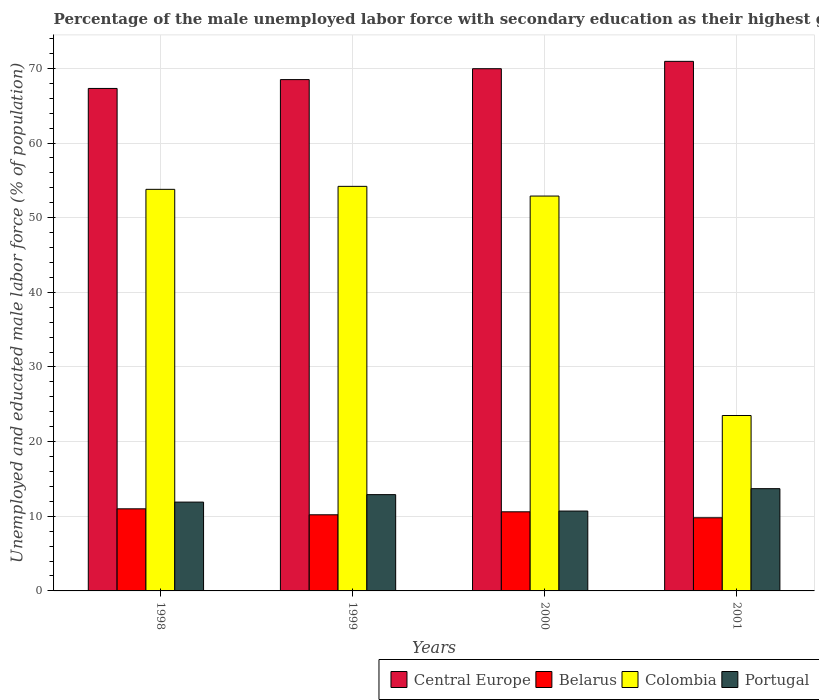How many groups of bars are there?
Offer a very short reply. 4. Are the number of bars on each tick of the X-axis equal?
Give a very brief answer. Yes. How many bars are there on the 1st tick from the right?
Offer a very short reply. 4. What is the label of the 2nd group of bars from the left?
Offer a very short reply. 1999. In how many cases, is the number of bars for a given year not equal to the number of legend labels?
Make the answer very short. 0. What is the percentage of the unemployed male labor force with secondary education in Belarus in 2000?
Make the answer very short. 10.6. Across all years, what is the maximum percentage of the unemployed male labor force with secondary education in Central Europe?
Your answer should be very brief. 70.95. Across all years, what is the minimum percentage of the unemployed male labor force with secondary education in Belarus?
Your answer should be very brief. 9.8. In which year was the percentage of the unemployed male labor force with secondary education in Colombia maximum?
Provide a succinct answer. 1999. In which year was the percentage of the unemployed male labor force with secondary education in Portugal minimum?
Offer a terse response. 2000. What is the total percentage of the unemployed male labor force with secondary education in Colombia in the graph?
Your answer should be compact. 184.4. What is the difference between the percentage of the unemployed male labor force with secondary education in Colombia in 1999 and that in 2000?
Your response must be concise. 1.3. What is the difference between the percentage of the unemployed male labor force with secondary education in Colombia in 2000 and the percentage of the unemployed male labor force with secondary education in Central Europe in 2001?
Your answer should be compact. -18.05. What is the average percentage of the unemployed male labor force with secondary education in Colombia per year?
Give a very brief answer. 46.1. In the year 1999, what is the difference between the percentage of the unemployed male labor force with secondary education in Portugal and percentage of the unemployed male labor force with secondary education in Central Europe?
Ensure brevity in your answer.  -55.6. In how many years, is the percentage of the unemployed male labor force with secondary education in Portugal greater than 56 %?
Keep it short and to the point. 0. What is the ratio of the percentage of the unemployed male labor force with secondary education in Colombia in 1998 to that in 2001?
Make the answer very short. 2.29. Is the percentage of the unemployed male labor force with secondary education in Portugal in 1998 less than that in 1999?
Offer a terse response. Yes. What is the difference between the highest and the second highest percentage of the unemployed male labor force with secondary education in Central Europe?
Your response must be concise. 0.99. What is the difference between the highest and the lowest percentage of the unemployed male labor force with secondary education in Belarus?
Offer a terse response. 1.2. In how many years, is the percentage of the unemployed male labor force with secondary education in Central Europe greater than the average percentage of the unemployed male labor force with secondary education in Central Europe taken over all years?
Your answer should be compact. 2. What does the 1st bar from the left in 1998 represents?
Provide a succinct answer. Central Europe. How many years are there in the graph?
Make the answer very short. 4. Where does the legend appear in the graph?
Your response must be concise. Bottom right. What is the title of the graph?
Provide a short and direct response. Percentage of the male unemployed labor force with secondary education as their highest grade. What is the label or title of the Y-axis?
Offer a terse response. Unemployed and educated male labor force (% of population). What is the Unemployed and educated male labor force (% of population) in Central Europe in 1998?
Provide a succinct answer. 67.32. What is the Unemployed and educated male labor force (% of population) in Belarus in 1998?
Make the answer very short. 11. What is the Unemployed and educated male labor force (% of population) of Colombia in 1998?
Provide a succinct answer. 53.8. What is the Unemployed and educated male labor force (% of population) of Portugal in 1998?
Provide a succinct answer. 11.9. What is the Unemployed and educated male labor force (% of population) in Central Europe in 1999?
Give a very brief answer. 68.5. What is the Unemployed and educated male labor force (% of population) in Belarus in 1999?
Provide a succinct answer. 10.2. What is the Unemployed and educated male labor force (% of population) in Colombia in 1999?
Offer a terse response. 54.2. What is the Unemployed and educated male labor force (% of population) of Portugal in 1999?
Your answer should be compact. 12.9. What is the Unemployed and educated male labor force (% of population) in Central Europe in 2000?
Your response must be concise. 69.96. What is the Unemployed and educated male labor force (% of population) of Belarus in 2000?
Make the answer very short. 10.6. What is the Unemployed and educated male labor force (% of population) in Colombia in 2000?
Offer a very short reply. 52.9. What is the Unemployed and educated male labor force (% of population) in Portugal in 2000?
Make the answer very short. 10.7. What is the Unemployed and educated male labor force (% of population) of Central Europe in 2001?
Your response must be concise. 70.95. What is the Unemployed and educated male labor force (% of population) of Belarus in 2001?
Offer a terse response. 9.8. What is the Unemployed and educated male labor force (% of population) in Portugal in 2001?
Provide a succinct answer. 13.7. Across all years, what is the maximum Unemployed and educated male labor force (% of population) in Central Europe?
Give a very brief answer. 70.95. Across all years, what is the maximum Unemployed and educated male labor force (% of population) of Belarus?
Provide a short and direct response. 11. Across all years, what is the maximum Unemployed and educated male labor force (% of population) in Colombia?
Offer a terse response. 54.2. Across all years, what is the maximum Unemployed and educated male labor force (% of population) of Portugal?
Offer a terse response. 13.7. Across all years, what is the minimum Unemployed and educated male labor force (% of population) of Central Europe?
Make the answer very short. 67.32. Across all years, what is the minimum Unemployed and educated male labor force (% of population) of Belarus?
Your response must be concise. 9.8. Across all years, what is the minimum Unemployed and educated male labor force (% of population) in Colombia?
Your answer should be very brief. 23.5. Across all years, what is the minimum Unemployed and educated male labor force (% of population) in Portugal?
Make the answer very short. 10.7. What is the total Unemployed and educated male labor force (% of population) in Central Europe in the graph?
Make the answer very short. 276.73. What is the total Unemployed and educated male labor force (% of population) of Belarus in the graph?
Your response must be concise. 41.6. What is the total Unemployed and educated male labor force (% of population) in Colombia in the graph?
Your response must be concise. 184.4. What is the total Unemployed and educated male labor force (% of population) in Portugal in the graph?
Your answer should be compact. 49.2. What is the difference between the Unemployed and educated male labor force (% of population) in Central Europe in 1998 and that in 1999?
Offer a terse response. -1.18. What is the difference between the Unemployed and educated male labor force (% of population) in Belarus in 1998 and that in 1999?
Your answer should be very brief. 0.8. What is the difference between the Unemployed and educated male labor force (% of population) in Colombia in 1998 and that in 1999?
Provide a short and direct response. -0.4. What is the difference between the Unemployed and educated male labor force (% of population) in Portugal in 1998 and that in 1999?
Offer a terse response. -1. What is the difference between the Unemployed and educated male labor force (% of population) in Central Europe in 1998 and that in 2000?
Your response must be concise. -2.64. What is the difference between the Unemployed and educated male labor force (% of population) of Belarus in 1998 and that in 2000?
Keep it short and to the point. 0.4. What is the difference between the Unemployed and educated male labor force (% of population) in Portugal in 1998 and that in 2000?
Offer a very short reply. 1.2. What is the difference between the Unemployed and educated male labor force (% of population) of Central Europe in 1998 and that in 2001?
Ensure brevity in your answer.  -3.63. What is the difference between the Unemployed and educated male labor force (% of population) of Colombia in 1998 and that in 2001?
Your answer should be very brief. 30.3. What is the difference between the Unemployed and educated male labor force (% of population) of Portugal in 1998 and that in 2001?
Make the answer very short. -1.8. What is the difference between the Unemployed and educated male labor force (% of population) in Central Europe in 1999 and that in 2000?
Offer a very short reply. -1.46. What is the difference between the Unemployed and educated male labor force (% of population) in Belarus in 1999 and that in 2000?
Provide a short and direct response. -0.4. What is the difference between the Unemployed and educated male labor force (% of population) of Portugal in 1999 and that in 2000?
Offer a terse response. 2.2. What is the difference between the Unemployed and educated male labor force (% of population) in Central Europe in 1999 and that in 2001?
Give a very brief answer. -2.44. What is the difference between the Unemployed and educated male labor force (% of population) of Belarus in 1999 and that in 2001?
Your answer should be compact. 0.4. What is the difference between the Unemployed and educated male labor force (% of population) in Colombia in 1999 and that in 2001?
Offer a terse response. 30.7. What is the difference between the Unemployed and educated male labor force (% of population) in Central Europe in 2000 and that in 2001?
Ensure brevity in your answer.  -0.99. What is the difference between the Unemployed and educated male labor force (% of population) in Belarus in 2000 and that in 2001?
Offer a terse response. 0.8. What is the difference between the Unemployed and educated male labor force (% of population) in Colombia in 2000 and that in 2001?
Your answer should be compact. 29.4. What is the difference between the Unemployed and educated male labor force (% of population) in Portugal in 2000 and that in 2001?
Keep it short and to the point. -3. What is the difference between the Unemployed and educated male labor force (% of population) in Central Europe in 1998 and the Unemployed and educated male labor force (% of population) in Belarus in 1999?
Make the answer very short. 57.12. What is the difference between the Unemployed and educated male labor force (% of population) in Central Europe in 1998 and the Unemployed and educated male labor force (% of population) in Colombia in 1999?
Provide a succinct answer. 13.12. What is the difference between the Unemployed and educated male labor force (% of population) in Central Europe in 1998 and the Unemployed and educated male labor force (% of population) in Portugal in 1999?
Your answer should be compact. 54.42. What is the difference between the Unemployed and educated male labor force (% of population) of Belarus in 1998 and the Unemployed and educated male labor force (% of population) of Colombia in 1999?
Provide a short and direct response. -43.2. What is the difference between the Unemployed and educated male labor force (% of population) in Colombia in 1998 and the Unemployed and educated male labor force (% of population) in Portugal in 1999?
Your answer should be compact. 40.9. What is the difference between the Unemployed and educated male labor force (% of population) of Central Europe in 1998 and the Unemployed and educated male labor force (% of population) of Belarus in 2000?
Keep it short and to the point. 56.72. What is the difference between the Unemployed and educated male labor force (% of population) in Central Europe in 1998 and the Unemployed and educated male labor force (% of population) in Colombia in 2000?
Your response must be concise. 14.42. What is the difference between the Unemployed and educated male labor force (% of population) of Central Europe in 1998 and the Unemployed and educated male labor force (% of population) of Portugal in 2000?
Make the answer very short. 56.62. What is the difference between the Unemployed and educated male labor force (% of population) of Belarus in 1998 and the Unemployed and educated male labor force (% of population) of Colombia in 2000?
Make the answer very short. -41.9. What is the difference between the Unemployed and educated male labor force (% of population) of Belarus in 1998 and the Unemployed and educated male labor force (% of population) of Portugal in 2000?
Your answer should be very brief. 0.3. What is the difference between the Unemployed and educated male labor force (% of population) of Colombia in 1998 and the Unemployed and educated male labor force (% of population) of Portugal in 2000?
Your answer should be very brief. 43.1. What is the difference between the Unemployed and educated male labor force (% of population) in Central Europe in 1998 and the Unemployed and educated male labor force (% of population) in Belarus in 2001?
Ensure brevity in your answer.  57.52. What is the difference between the Unemployed and educated male labor force (% of population) in Central Europe in 1998 and the Unemployed and educated male labor force (% of population) in Colombia in 2001?
Ensure brevity in your answer.  43.82. What is the difference between the Unemployed and educated male labor force (% of population) in Central Europe in 1998 and the Unemployed and educated male labor force (% of population) in Portugal in 2001?
Offer a very short reply. 53.62. What is the difference between the Unemployed and educated male labor force (% of population) in Belarus in 1998 and the Unemployed and educated male labor force (% of population) in Portugal in 2001?
Your answer should be compact. -2.7. What is the difference between the Unemployed and educated male labor force (% of population) in Colombia in 1998 and the Unemployed and educated male labor force (% of population) in Portugal in 2001?
Offer a very short reply. 40.1. What is the difference between the Unemployed and educated male labor force (% of population) of Central Europe in 1999 and the Unemployed and educated male labor force (% of population) of Belarus in 2000?
Provide a short and direct response. 57.9. What is the difference between the Unemployed and educated male labor force (% of population) in Central Europe in 1999 and the Unemployed and educated male labor force (% of population) in Colombia in 2000?
Provide a succinct answer. 15.6. What is the difference between the Unemployed and educated male labor force (% of population) in Central Europe in 1999 and the Unemployed and educated male labor force (% of population) in Portugal in 2000?
Your response must be concise. 57.8. What is the difference between the Unemployed and educated male labor force (% of population) of Belarus in 1999 and the Unemployed and educated male labor force (% of population) of Colombia in 2000?
Provide a succinct answer. -42.7. What is the difference between the Unemployed and educated male labor force (% of population) of Colombia in 1999 and the Unemployed and educated male labor force (% of population) of Portugal in 2000?
Provide a short and direct response. 43.5. What is the difference between the Unemployed and educated male labor force (% of population) in Central Europe in 1999 and the Unemployed and educated male labor force (% of population) in Belarus in 2001?
Your answer should be compact. 58.7. What is the difference between the Unemployed and educated male labor force (% of population) of Central Europe in 1999 and the Unemployed and educated male labor force (% of population) of Colombia in 2001?
Provide a succinct answer. 45. What is the difference between the Unemployed and educated male labor force (% of population) in Central Europe in 1999 and the Unemployed and educated male labor force (% of population) in Portugal in 2001?
Provide a succinct answer. 54.8. What is the difference between the Unemployed and educated male labor force (% of population) in Belarus in 1999 and the Unemployed and educated male labor force (% of population) in Portugal in 2001?
Provide a short and direct response. -3.5. What is the difference between the Unemployed and educated male labor force (% of population) in Colombia in 1999 and the Unemployed and educated male labor force (% of population) in Portugal in 2001?
Ensure brevity in your answer.  40.5. What is the difference between the Unemployed and educated male labor force (% of population) of Central Europe in 2000 and the Unemployed and educated male labor force (% of population) of Belarus in 2001?
Your answer should be very brief. 60.16. What is the difference between the Unemployed and educated male labor force (% of population) of Central Europe in 2000 and the Unemployed and educated male labor force (% of population) of Colombia in 2001?
Make the answer very short. 46.46. What is the difference between the Unemployed and educated male labor force (% of population) of Central Europe in 2000 and the Unemployed and educated male labor force (% of population) of Portugal in 2001?
Offer a terse response. 56.26. What is the difference between the Unemployed and educated male labor force (% of population) in Colombia in 2000 and the Unemployed and educated male labor force (% of population) in Portugal in 2001?
Ensure brevity in your answer.  39.2. What is the average Unemployed and educated male labor force (% of population) in Central Europe per year?
Your answer should be compact. 69.18. What is the average Unemployed and educated male labor force (% of population) of Colombia per year?
Your response must be concise. 46.1. In the year 1998, what is the difference between the Unemployed and educated male labor force (% of population) in Central Europe and Unemployed and educated male labor force (% of population) in Belarus?
Make the answer very short. 56.32. In the year 1998, what is the difference between the Unemployed and educated male labor force (% of population) of Central Europe and Unemployed and educated male labor force (% of population) of Colombia?
Make the answer very short. 13.52. In the year 1998, what is the difference between the Unemployed and educated male labor force (% of population) of Central Europe and Unemployed and educated male labor force (% of population) of Portugal?
Your answer should be very brief. 55.42. In the year 1998, what is the difference between the Unemployed and educated male labor force (% of population) in Belarus and Unemployed and educated male labor force (% of population) in Colombia?
Your answer should be compact. -42.8. In the year 1998, what is the difference between the Unemployed and educated male labor force (% of population) of Colombia and Unemployed and educated male labor force (% of population) of Portugal?
Keep it short and to the point. 41.9. In the year 1999, what is the difference between the Unemployed and educated male labor force (% of population) in Central Europe and Unemployed and educated male labor force (% of population) in Belarus?
Offer a terse response. 58.3. In the year 1999, what is the difference between the Unemployed and educated male labor force (% of population) of Central Europe and Unemployed and educated male labor force (% of population) of Colombia?
Ensure brevity in your answer.  14.3. In the year 1999, what is the difference between the Unemployed and educated male labor force (% of population) of Central Europe and Unemployed and educated male labor force (% of population) of Portugal?
Offer a very short reply. 55.6. In the year 1999, what is the difference between the Unemployed and educated male labor force (% of population) of Belarus and Unemployed and educated male labor force (% of population) of Colombia?
Your answer should be compact. -44. In the year 1999, what is the difference between the Unemployed and educated male labor force (% of population) in Belarus and Unemployed and educated male labor force (% of population) in Portugal?
Make the answer very short. -2.7. In the year 1999, what is the difference between the Unemployed and educated male labor force (% of population) of Colombia and Unemployed and educated male labor force (% of population) of Portugal?
Offer a terse response. 41.3. In the year 2000, what is the difference between the Unemployed and educated male labor force (% of population) of Central Europe and Unemployed and educated male labor force (% of population) of Belarus?
Your answer should be very brief. 59.36. In the year 2000, what is the difference between the Unemployed and educated male labor force (% of population) of Central Europe and Unemployed and educated male labor force (% of population) of Colombia?
Make the answer very short. 17.06. In the year 2000, what is the difference between the Unemployed and educated male labor force (% of population) of Central Europe and Unemployed and educated male labor force (% of population) of Portugal?
Your response must be concise. 59.26. In the year 2000, what is the difference between the Unemployed and educated male labor force (% of population) in Belarus and Unemployed and educated male labor force (% of population) in Colombia?
Your answer should be compact. -42.3. In the year 2000, what is the difference between the Unemployed and educated male labor force (% of population) in Colombia and Unemployed and educated male labor force (% of population) in Portugal?
Ensure brevity in your answer.  42.2. In the year 2001, what is the difference between the Unemployed and educated male labor force (% of population) in Central Europe and Unemployed and educated male labor force (% of population) in Belarus?
Give a very brief answer. 61.15. In the year 2001, what is the difference between the Unemployed and educated male labor force (% of population) of Central Europe and Unemployed and educated male labor force (% of population) of Colombia?
Ensure brevity in your answer.  47.45. In the year 2001, what is the difference between the Unemployed and educated male labor force (% of population) in Central Europe and Unemployed and educated male labor force (% of population) in Portugal?
Your answer should be compact. 57.25. In the year 2001, what is the difference between the Unemployed and educated male labor force (% of population) of Belarus and Unemployed and educated male labor force (% of population) of Colombia?
Offer a terse response. -13.7. In the year 2001, what is the difference between the Unemployed and educated male labor force (% of population) of Belarus and Unemployed and educated male labor force (% of population) of Portugal?
Make the answer very short. -3.9. In the year 2001, what is the difference between the Unemployed and educated male labor force (% of population) of Colombia and Unemployed and educated male labor force (% of population) of Portugal?
Provide a short and direct response. 9.8. What is the ratio of the Unemployed and educated male labor force (% of population) in Central Europe in 1998 to that in 1999?
Keep it short and to the point. 0.98. What is the ratio of the Unemployed and educated male labor force (% of population) in Belarus in 1998 to that in 1999?
Ensure brevity in your answer.  1.08. What is the ratio of the Unemployed and educated male labor force (% of population) in Colombia in 1998 to that in 1999?
Your answer should be compact. 0.99. What is the ratio of the Unemployed and educated male labor force (% of population) in Portugal in 1998 to that in 1999?
Offer a terse response. 0.92. What is the ratio of the Unemployed and educated male labor force (% of population) of Central Europe in 1998 to that in 2000?
Your response must be concise. 0.96. What is the ratio of the Unemployed and educated male labor force (% of population) in Belarus in 1998 to that in 2000?
Make the answer very short. 1.04. What is the ratio of the Unemployed and educated male labor force (% of population) in Portugal in 1998 to that in 2000?
Keep it short and to the point. 1.11. What is the ratio of the Unemployed and educated male labor force (% of population) in Central Europe in 1998 to that in 2001?
Your response must be concise. 0.95. What is the ratio of the Unemployed and educated male labor force (% of population) in Belarus in 1998 to that in 2001?
Offer a very short reply. 1.12. What is the ratio of the Unemployed and educated male labor force (% of population) in Colombia in 1998 to that in 2001?
Give a very brief answer. 2.29. What is the ratio of the Unemployed and educated male labor force (% of population) in Portugal in 1998 to that in 2001?
Your response must be concise. 0.87. What is the ratio of the Unemployed and educated male labor force (% of population) in Central Europe in 1999 to that in 2000?
Your answer should be very brief. 0.98. What is the ratio of the Unemployed and educated male labor force (% of population) of Belarus in 1999 to that in 2000?
Ensure brevity in your answer.  0.96. What is the ratio of the Unemployed and educated male labor force (% of population) of Colombia in 1999 to that in 2000?
Your response must be concise. 1.02. What is the ratio of the Unemployed and educated male labor force (% of population) in Portugal in 1999 to that in 2000?
Your response must be concise. 1.21. What is the ratio of the Unemployed and educated male labor force (% of population) of Central Europe in 1999 to that in 2001?
Give a very brief answer. 0.97. What is the ratio of the Unemployed and educated male labor force (% of population) in Belarus in 1999 to that in 2001?
Your answer should be compact. 1.04. What is the ratio of the Unemployed and educated male labor force (% of population) of Colombia in 1999 to that in 2001?
Your response must be concise. 2.31. What is the ratio of the Unemployed and educated male labor force (% of population) of Portugal in 1999 to that in 2001?
Give a very brief answer. 0.94. What is the ratio of the Unemployed and educated male labor force (% of population) in Central Europe in 2000 to that in 2001?
Your response must be concise. 0.99. What is the ratio of the Unemployed and educated male labor force (% of population) of Belarus in 2000 to that in 2001?
Your response must be concise. 1.08. What is the ratio of the Unemployed and educated male labor force (% of population) of Colombia in 2000 to that in 2001?
Ensure brevity in your answer.  2.25. What is the ratio of the Unemployed and educated male labor force (% of population) in Portugal in 2000 to that in 2001?
Make the answer very short. 0.78. What is the difference between the highest and the second highest Unemployed and educated male labor force (% of population) in Central Europe?
Your response must be concise. 0.99. What is the difference between the highest and the second highest Unemployed and educated male labor force (% of population) of Colombia?
Your answer should be very brief. 0.4. What is the difference between the highest and the second highest Unemployed and educated male labor force (% of population) in Portugal?
Provide a short and direct response. 0.8. What is the difference between the highest and the lowest Unemployed and educated male labor force (% of population) of Central Europe?
Offer a very short reply. 3.63. What is the difference between the highest and the lowest Unemployed and educated male labor force (% of population) in Belarus?
Your response must be concise. 1.2. What is the difference between the highest and the lowest Unemployed and educated male labor force (% of population) in Colombia?
Keep it short and to the point. 30.7. What is the difference between the highest and the lowest Unemployed and educated male labor force (% of population) of Portugal?
Your answer should be compact. 3. 